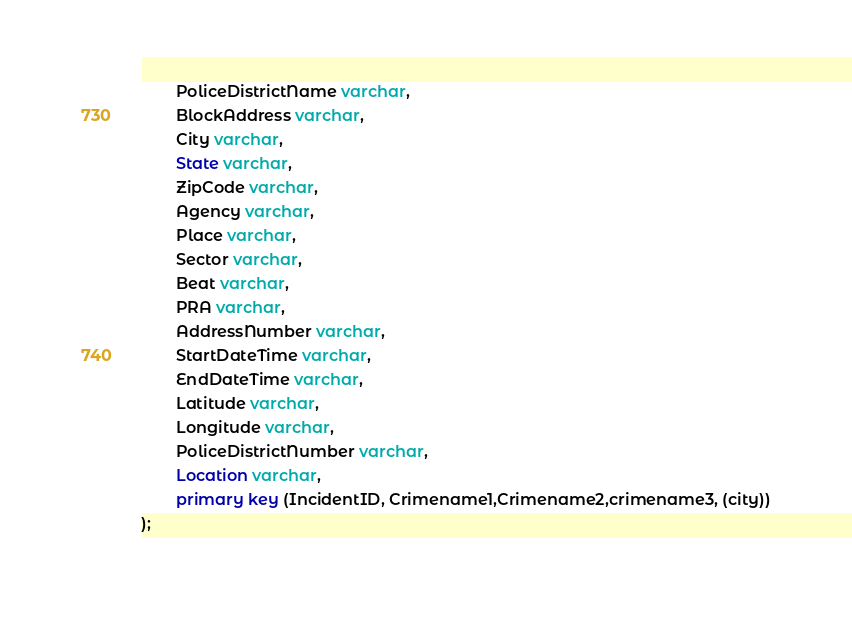<code> <loc_0><loc_0><loc_500><loc_500><_SQL_>        PoliceDistrictName varchar,
        BlockAddress varchar,
        City varchar,
        State varchar,
        ZipCode varchar,
        Agency varchar,
        Place varchar,
        Sector varchar,
        Beat varchar,
        PRA varchar,
        AddressNumber varchar,
        StartDateTime varchar,
        EndDateTime varchar,
        Latitude varchar,
        Longitude varchar,
        PoliceDistrictNumber varchar,
        Location varchar,
        primary key (IncidentID, Crimename1,Crimename2,crimename3, (city))
);</code> 